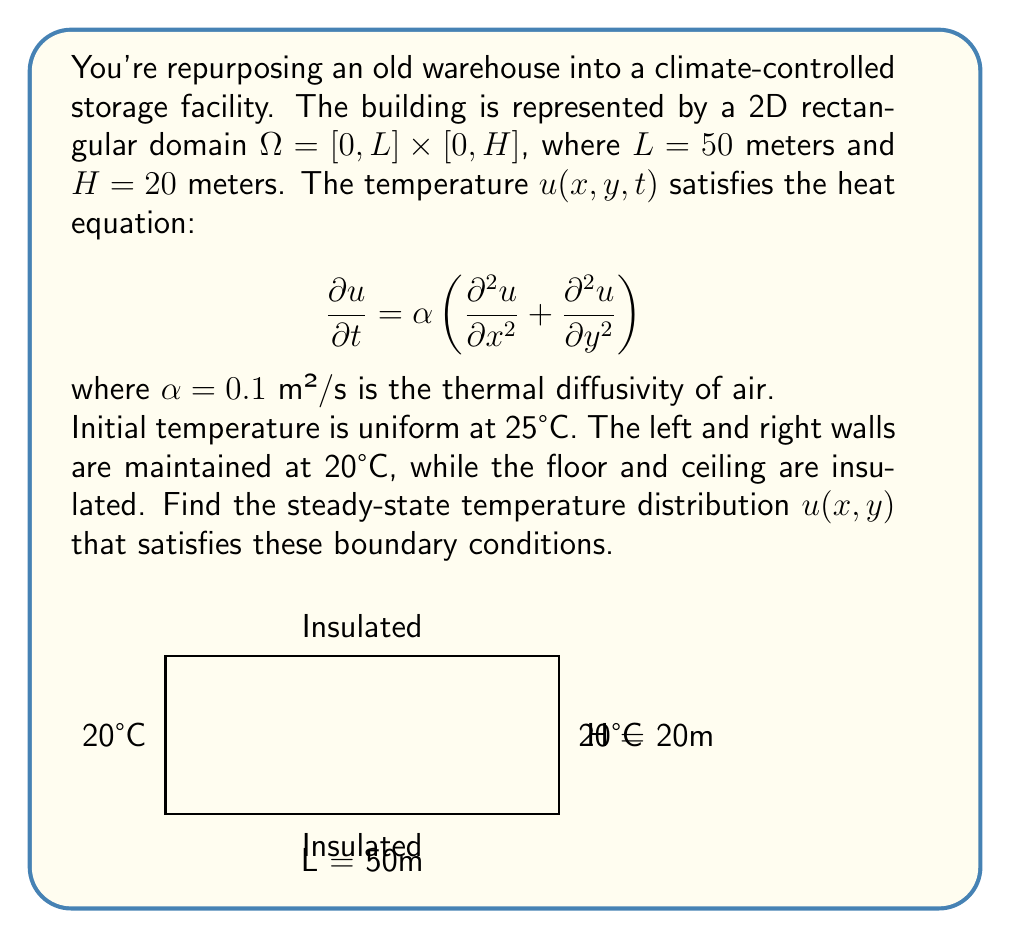What is the answer to this math problem? To solve this problem, we'll follow these steps:

1) For steady-state, $\frac{\partial u}{\partial t} = 0$, so the heat equation reduces to Laplace's equation:

   $$\frac{\partial^2 u}{\partial x^2} + \frac{\partial^2 u}{\partial y^2} = 0$$

2) The boundary conditions are:
   - $u(0, y) = u(L, y) = 20$ for $0 \leq y \leq H$
   - $\frac{\partial u}{\partial y}(x, 0) = \frac{\partial u}{\partial y}(x, H) = 0$ for $0 \leq x \leq L$

3) We can solve this using separation of variables. Let $u(x, y) = X(x)Y(y)$. Substituting into Laplace's equation:

   $$X''(x)Y(y) + X(x)Y''(y) = 0$$
   $$\frac{X''(x)}{X(x)} = -\frac{Y''(y)}{Y(y)} = -\lambda^2$$

4) This gives us two ODEs:
   $$X''(x) + \lambda^2 X(x) = 0$$
   $$Y''(y) - \lambda^2 Y(y) = 0$$

5) The general solutions are:
   $$X(x) = A \cos(\lambda x) + B \sin(\lambda x)$$
   $$Y(y) = C e^{\lambda y} + D e^{-\lambda y}$$

6) Applying the boundary conditions for $Y(y)$:
   $$Y'(0) = Y'(H) = 0 \implies C = D \text{ and } \lambda = \frac{n\pi}{H}$$

   So $Y_n(y) = C_n \cosh(\frac{n\pi y}{H})$

7) For $X(x)$, we need $X(0) = X(L) = 20$. This is satisfied by:
   $$X_n(x) = 20 + b_n \sin(\frac{n\pi x}{L})$$

8) The complete solution is:
   $$u(x, y) = 20 + \sum_{n=1}^{\infty} b_n \sin(\frac{n\pi x}{L}) \cosh(\frac{n\pi y}{H})$$

9) The coefficients $b_n$ can be found using Fourier series:
   $$b_n = \frac{2}{L} \int_0^L (25 - 20) \sin(\frac{n\pi x}{L}) dx = \frac{10}{n\pi}(1 - \cos(n\pi))$$

10) The final solution is:
    $$u(x, y) = 20 + \sum_{n=1}^{\infty} \frac{20}{n\pi}(1 - \cos(n\pi)) \sin(\frac{n\pi x}{L}) \cosh(\frac{n\pi y}{H})$$
Answer: $u(x, y) = 20 + \sum_{n=1}^{\infty} \frac{20}{n\pi}(1 - \cos(n\pi)) \sin(\frac{n\pi x}{50}) \cosh(\frac{n\pi y}{20})$ 